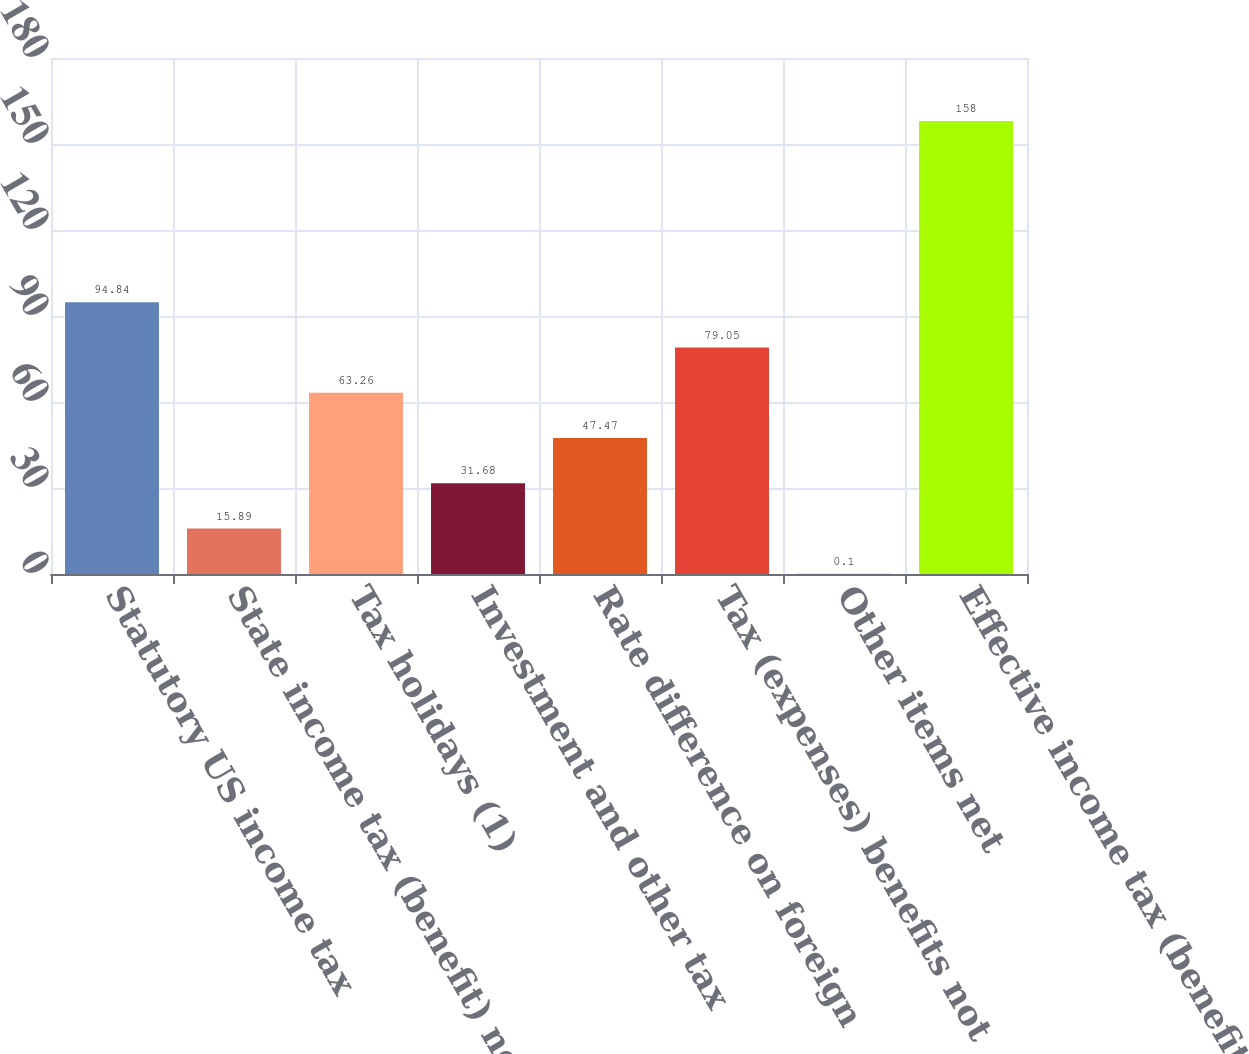<chart> <loc_0><loc_0><loc_500><loc_500><bar_chart><fcel>Statutory US income tax<fcel>State income tax (benefit) net<fcel>Tax holidays (1)<fcel>Investment and other tax<fcel>Rate difference on foreign<fcel>Tax (expenses) benefits not<fcel>Other items net<fcel>Effective income tax (benefit)<nl><fcel>94.84<fcel>15.89<fcel>63.26<fcel>31.68<fcel>47.47<fcel>79.05<fcel>0.1<fcel>158<nl></chart> 